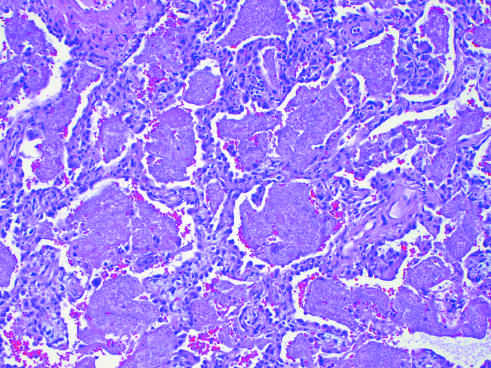re the alveoli filled with a characteristic foamy acellular exudate?
Answer the question using a single word or phrase. Yes 